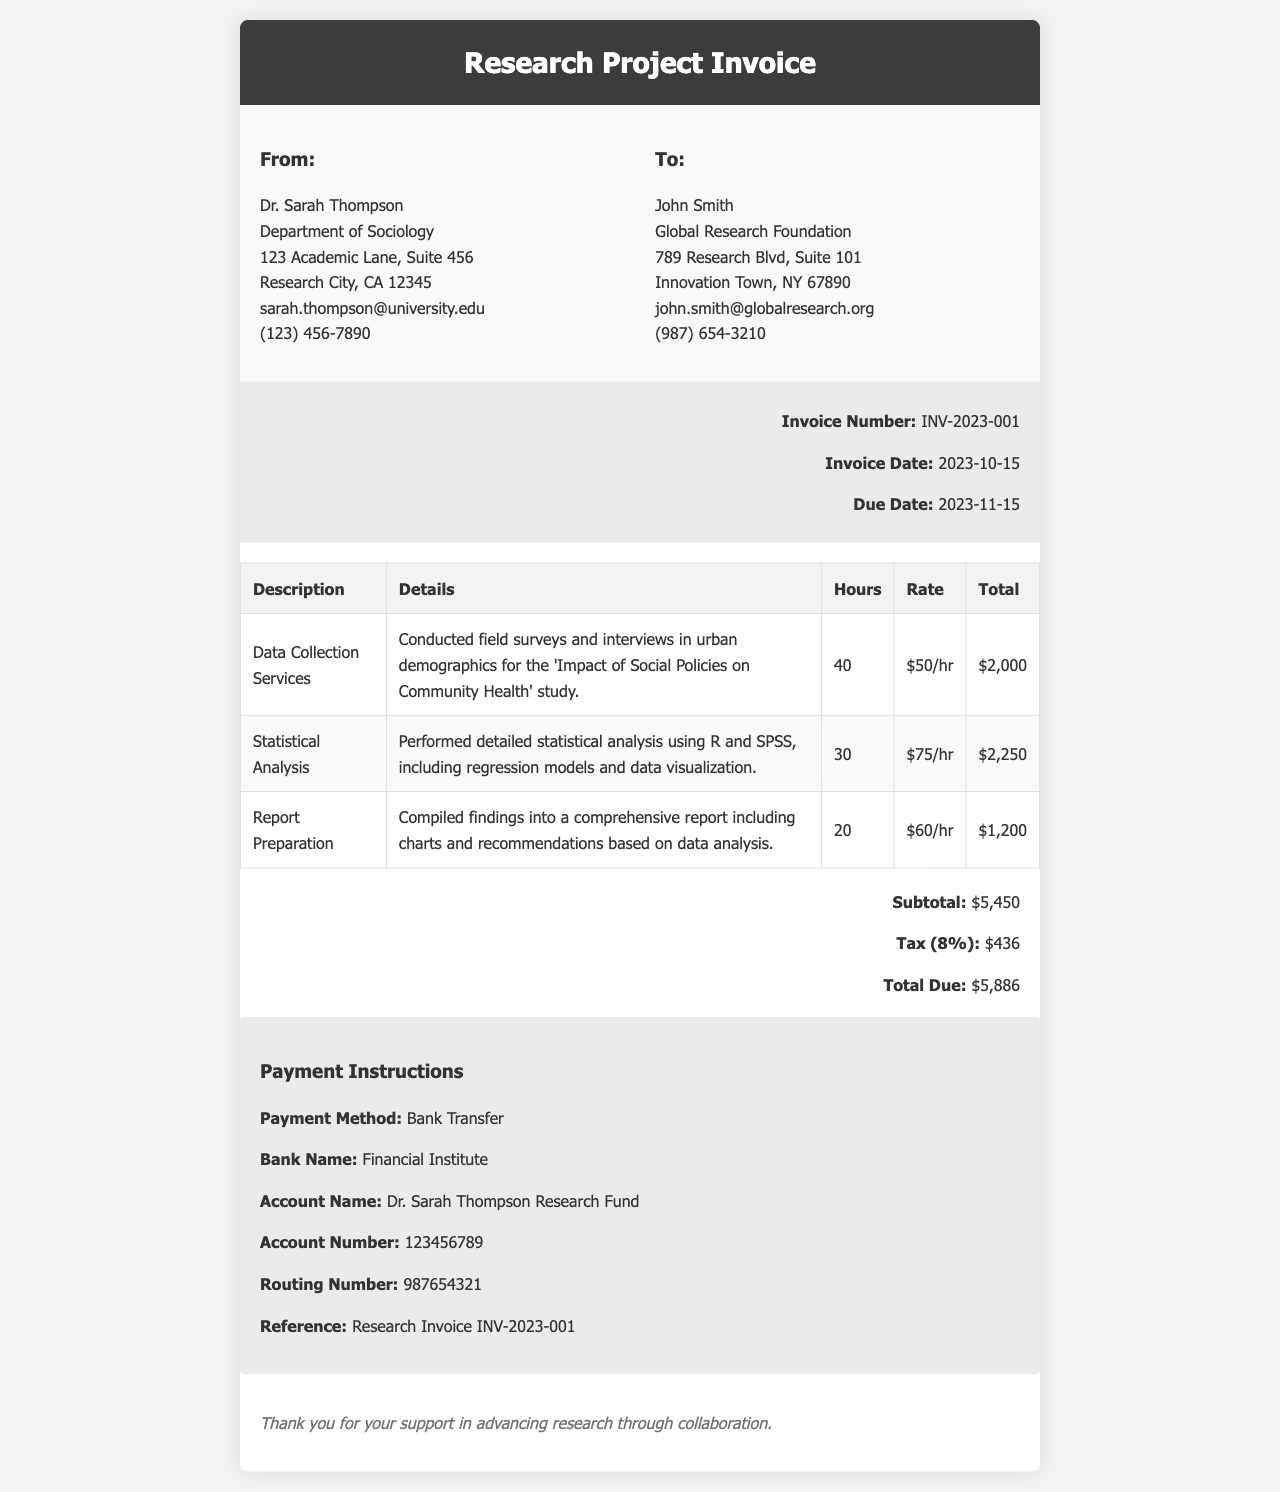What is the invoice number? The invoice number is specified in the document as a unique identifier for this invoice, which is INV-2023-001.
Answer: INV-2023-001 Who is the invoice addressed to? The invoice is addressed to John Smith, as indicated in the recipient section of the document.
Answer: John Smith What is the total amount due? The total amount due is presented at the end of the invoice under the summary section, which totals $5,886.
Answer: $5,886 How many hours were spent on Statistical Analysis? The hours spent on Statistical Analysis are listed in the services table, specifically as 30 hours.
Answer: 30 What is the tax rate applied to the invoice? The tax rate is detailed in the summary section of the invoice as 8%.
Answer: 8% What payment method is specified? The payment method stated in the payment instructions section is via Bank Transfer.
Answer: Bank Transfer What is the due date for the invoice? The due date is found in the invoice meta section, which specifies it as 2023-11-15.
Answer: 2023-11-15 How much was charged for report preparation? The cost for report preparation is detailed in the services table as $1,200.
Answer: $1,200 What is the name of the bank for the payment? The bank name for the payment is indicated in the payment instructions section as Financial Institute.
Answer: Financial Institute 